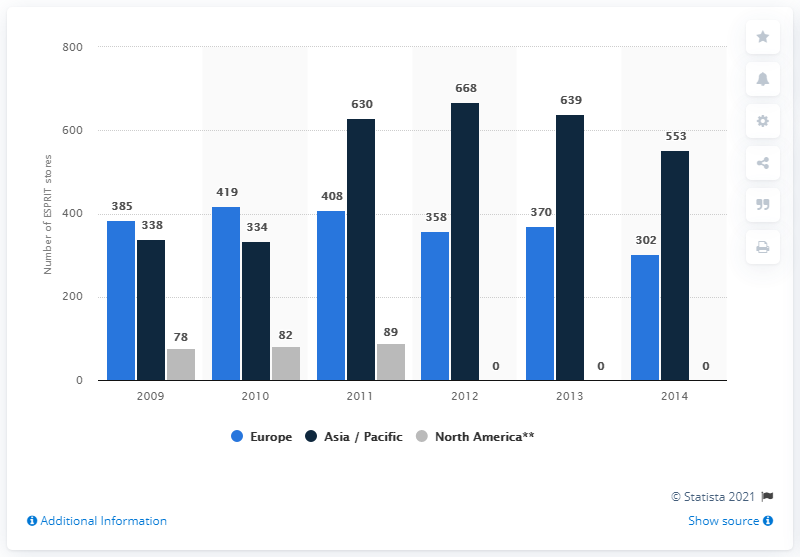Outline some significant characteristics in this image. In 2013, ESPRIT had a total of 370 retail stores across Europe. According to the data, the Asia / Pacific region had the highest number of retail stores in 2011. In 2011, the total number of stores was 1127. 